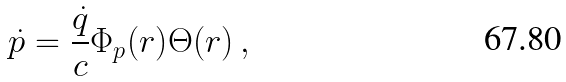Convert formula to latex. <formula><loc_0><loc_0><loc_500><loc_500>\dot { p } = \frac { \dot { q } } { c } { \Phi _ { p } ( r ) } { \Theta ( r ) } \, ,</formula> 